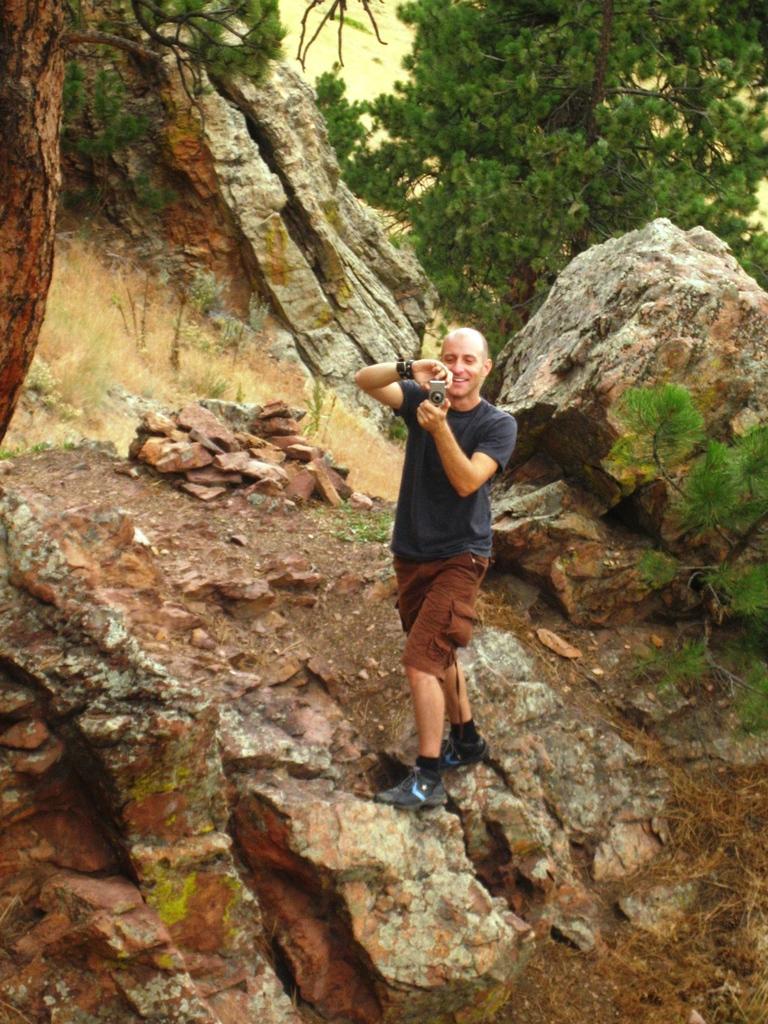Please provide a concise description of this image. In this image I can see a person standing wearing black color shirt, brown color short and holding a camera. Background I can see few rocks and trees in green color. 